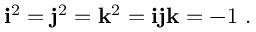<formula> <loc_0><loc_0><loc_500><loc_500>i ^ { 2 } = j ^ { 2 } = k ^ { 2 } = i j k = - 1 .</formula> 